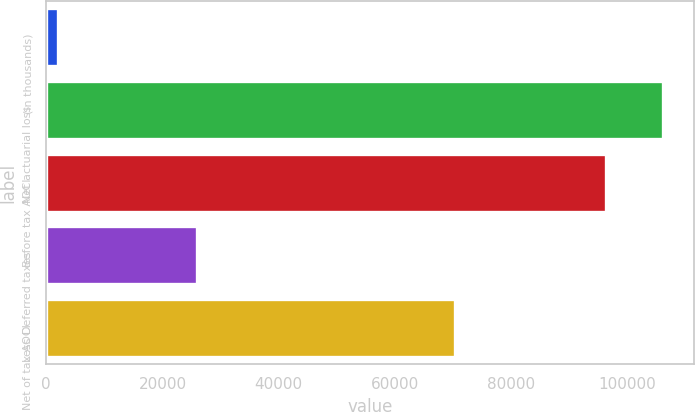Convert chart to OTSL. <chart><loc_0><loc_0><loc_500><loc_500><bar_chart><fcel>(in thousands)<fcel>Net actuarial loss<fcel>Before tax AOCI<fcel>Less Deferred taxes<fcel>Net of tax AOCI<nl><fcel>2012<fcel>106061<fcel>96349<fcel>25972<fcel>70377<nl></chart> 